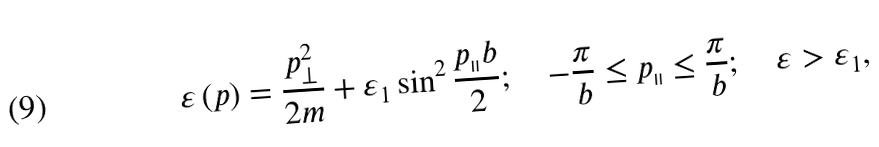Convert formula to latex. <formula><loc_0><loc_0><loc_500><loc_500>\varepsilon \left ( p \right ) = \frac { p _ { \perp } ^ { 2 } } { 2 m } + \varepsilon _ { 1 } \sin ^ { 2 } \frac { p _ { \shortparallel } b } { 2 } ; \quad - \frac { \pi } { b } \leq p _ { \shortparallel } \leq \frac { \pi } { b } ; \quad \varepsilon > \varepsilon _ { 1 } ,</formula> 